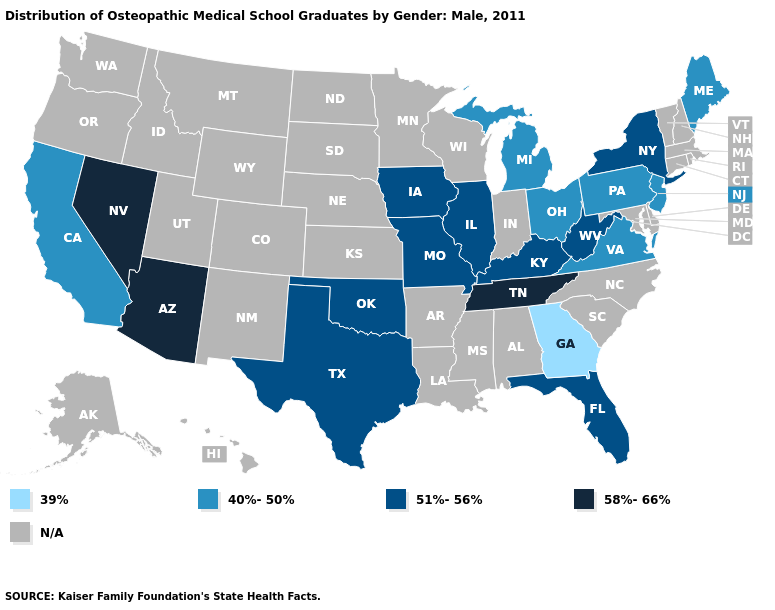What is the lowest value in states that border Colorado?
Be succinct. 51%-56%. How many symbols are there in the legend?
Quick response, please. 5. Does Illinois have the lowest value in the MidWest?
Concise answer only. No. Does Arizona have the highest value in the USA?
Quick response, please. Yes. What is the value of South Carolina?
Quick response, please. N/A. Name the states that have a value in the range N/A?
Answer briefly. Alabama, Alaska, Arkansas, Colorado, Connecticut, Delaware, Hawaii, Idaho, Indiana, Kansas, Louisiana, Maryland, Massachusetts, Minnesota, Mississippi, Montana, Nebraska, New Hampshire, New Mexico, North Carolina, North Dakota, Oregon, Rhode Island, South Carolina, South Dakota, Utah, Vermont, Washington, Wisconsin, Wyoming. Does Tennessee have the lowest value in the South?
Short answer required. No. Does the first symbol in the legend represent the smallest category?
Write a very short answer. Yes. Among the states that border Minnesota , which have the lowest value?
Concise answer only. Iowa. Among the states that border Nevada , does Arizona have the highest value?
Keep it brief. Yes. Name the states that have a value in the range 58%-66%?
Short answer required. Arizona, Nevada, Tennessee. Name the states that have a value in the range 39%?
Answer briefly. Georgia. Among the states that border West Virginia , which have the highest value?
Write a very short answer. Kentucky. Name the states that have a value in the range 39%?
Be succinct. Georgia. Among the states that border Illinois , which have the highest value?
Write a very short answer. Iowa, Kentucky, Missouri. 